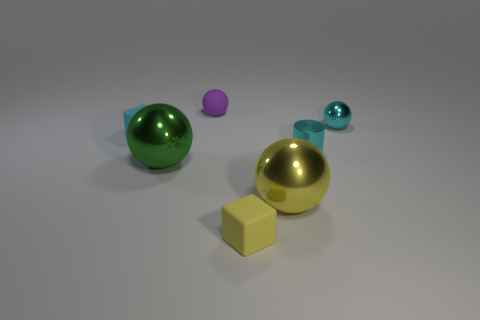Subtract all metal spheres. How many spheres are left? 1 Add 2 large red metallic things. How many objects exist? 9 Subtract all gray spheres. Subtract all gray cylinders. How many spheres are left? 4 Subtract all cylinders. How many objects are left? 6 Subtract 0 red blocks. How many objects are left? 7 Subtract all large yellow metal things. Subtract all small cubes. How many objects are left? 4 Add 4 yellow matte blocks. How many yellow matte blocks are left? 5 Add 5 big yellow objects. How many big yellow objects exist? 6 